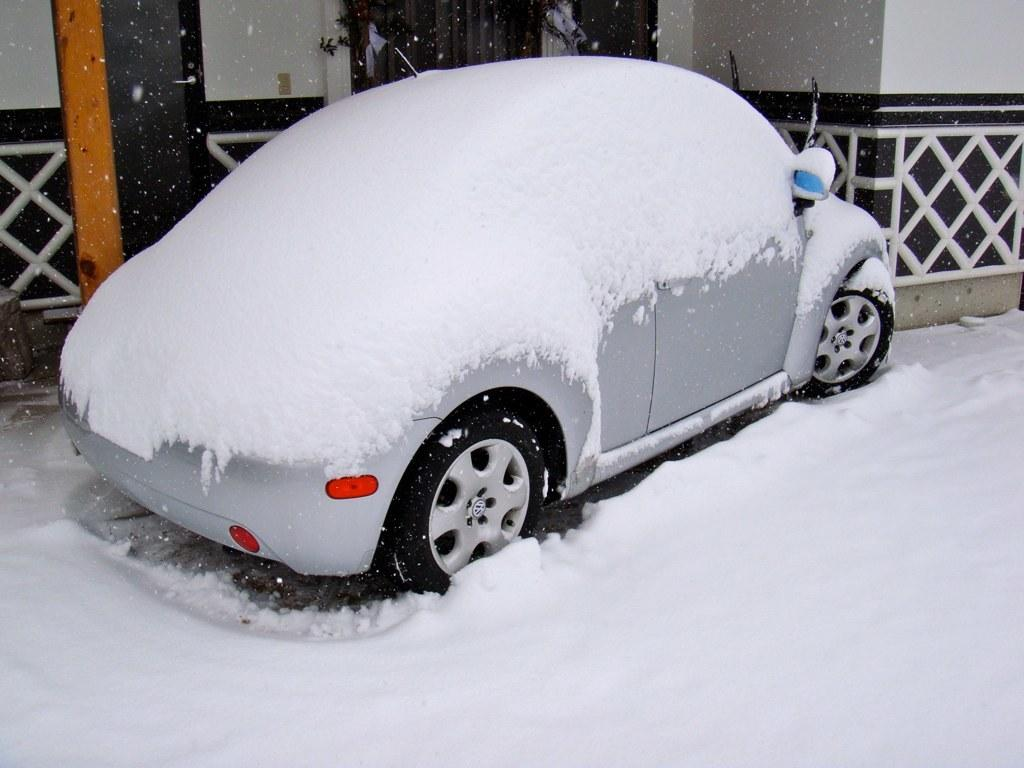What is the main subject of the image? The main subject of the image is a car. How is the car affected by the weather in the image? The car is covered with snow in the image. What is the condition of the ground in the image? The ground is covered with snow in the image. What other structure can be seen in the image? There is a building in the image. How is the building affected by the weather in the image? The building has snow on it in the image. What type of disease is being treated in the image? There is no indication of a disease or medical treatment in the image; it features a car and a building covered in snow. What is the chance of winning a prize in the image? There is no reference to a prize-winning or games in the image; it focuses on the car and building covered in snow. 